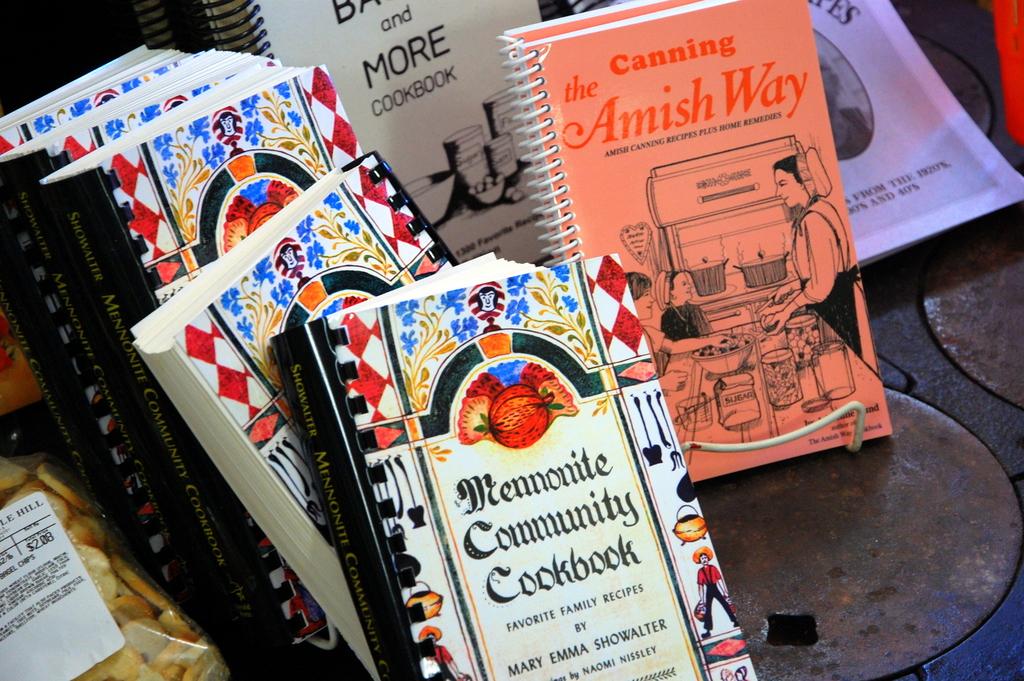What way is the canning book focused on?
Your answer should be compact. Amish. 